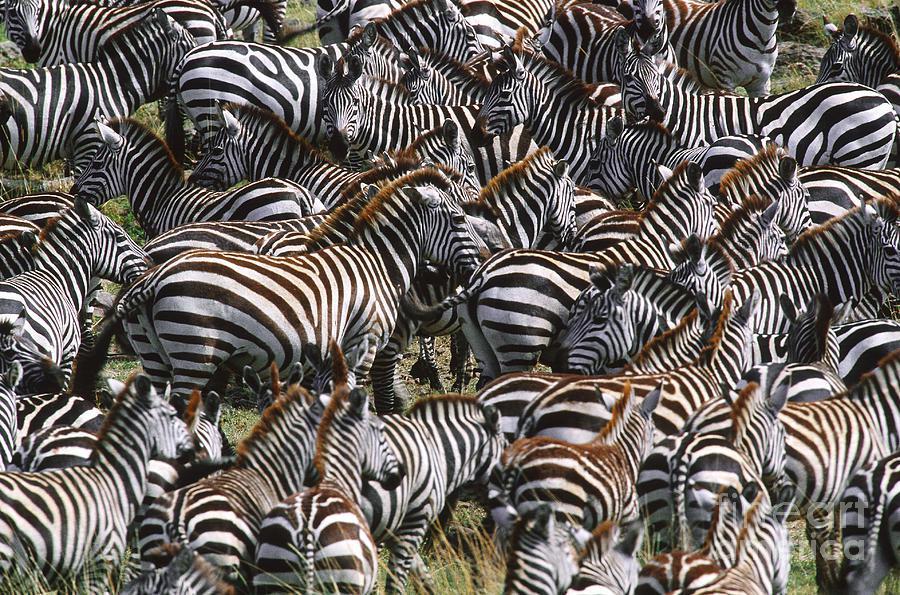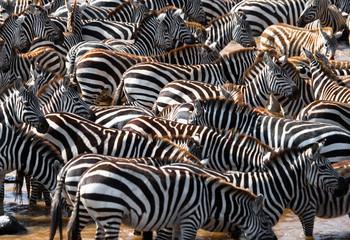The first image is the image on the left, the second image is the image on the right. Examine the images to the left and right. Is the description "One image shows zebras with necks extending from the right lined up to drink, with heads bent to the water." accurate? Answer yes or no. No. 